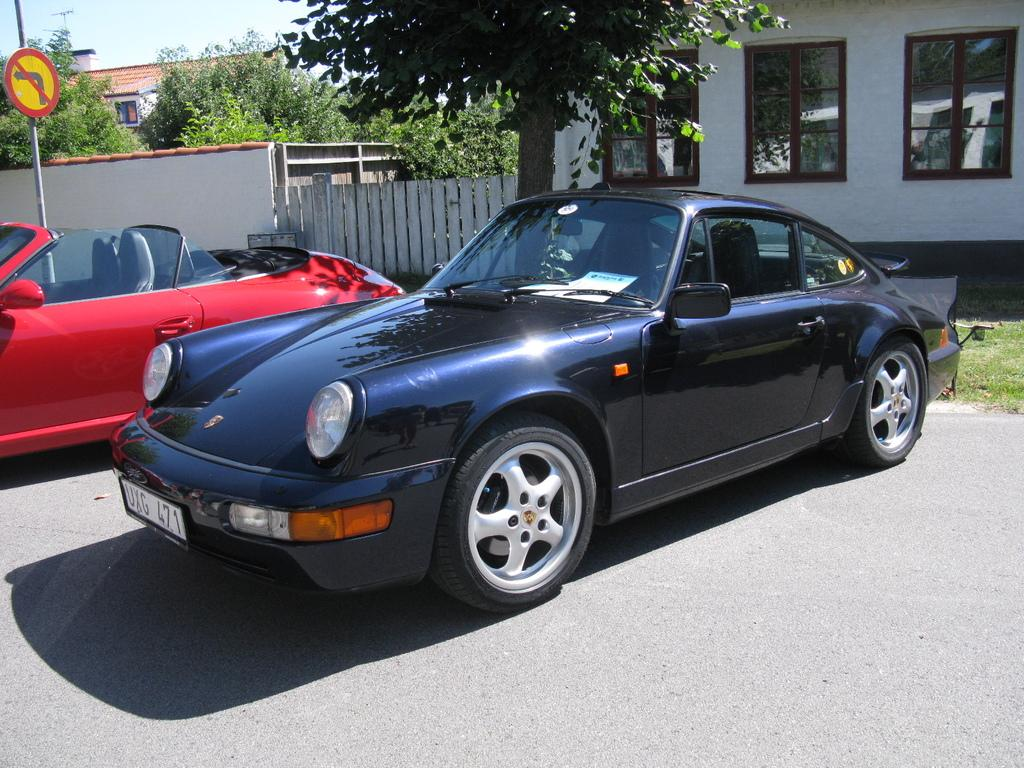What type of vehicles can be seen on the ground in the image? There are cars on the ground in the image. What is the tall, vertical object in the image? There is a pole in the image. What is the flat, rectangular object with writing or symbols in the image? There is a signboard in the image. What type of vegetation is present in the image? There are trees in the image. What type of structures are visible in the image? There are buildings with windows in the image. What other objects can be seen in the image? There are some objects in the image. What can be seen in the background of the image? The sky is visible in the background of the image. What type of wood is used to construct the buildings in the image? There is no information about the type of wood used to construct the buildings in the image. What details can be seen on the signboard in the image? The provided facts do not mention any specific details on the signboard in the image. How many days of the week are depicted in the image? There is no reference to days of the week in the image. 